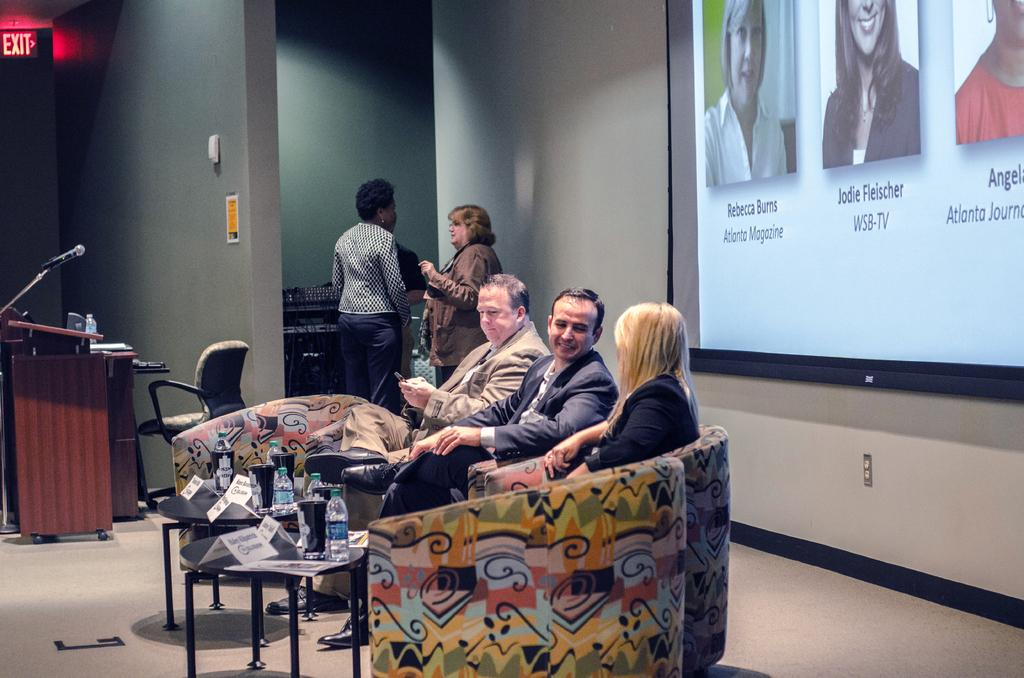What is the main subject of the image? The main subject of the image is a group of people. What are the people in the image doing? The people are sitting on chairs. What can be seen on the table in the image? There are water bottles on a table. Are there any other people in the image besides those sitting on chairs? Yes, there are two men standing in the image. What is the purpose of the projector screen visible in the image? The projector screen is likely used for presentations or displaying visuals. What type of creature is sitting on the projector screen in the image? There is no creature present on the projector screen in the image. How many clovers are visible on the table in the image? There are no clovers visible on the table in the image. 